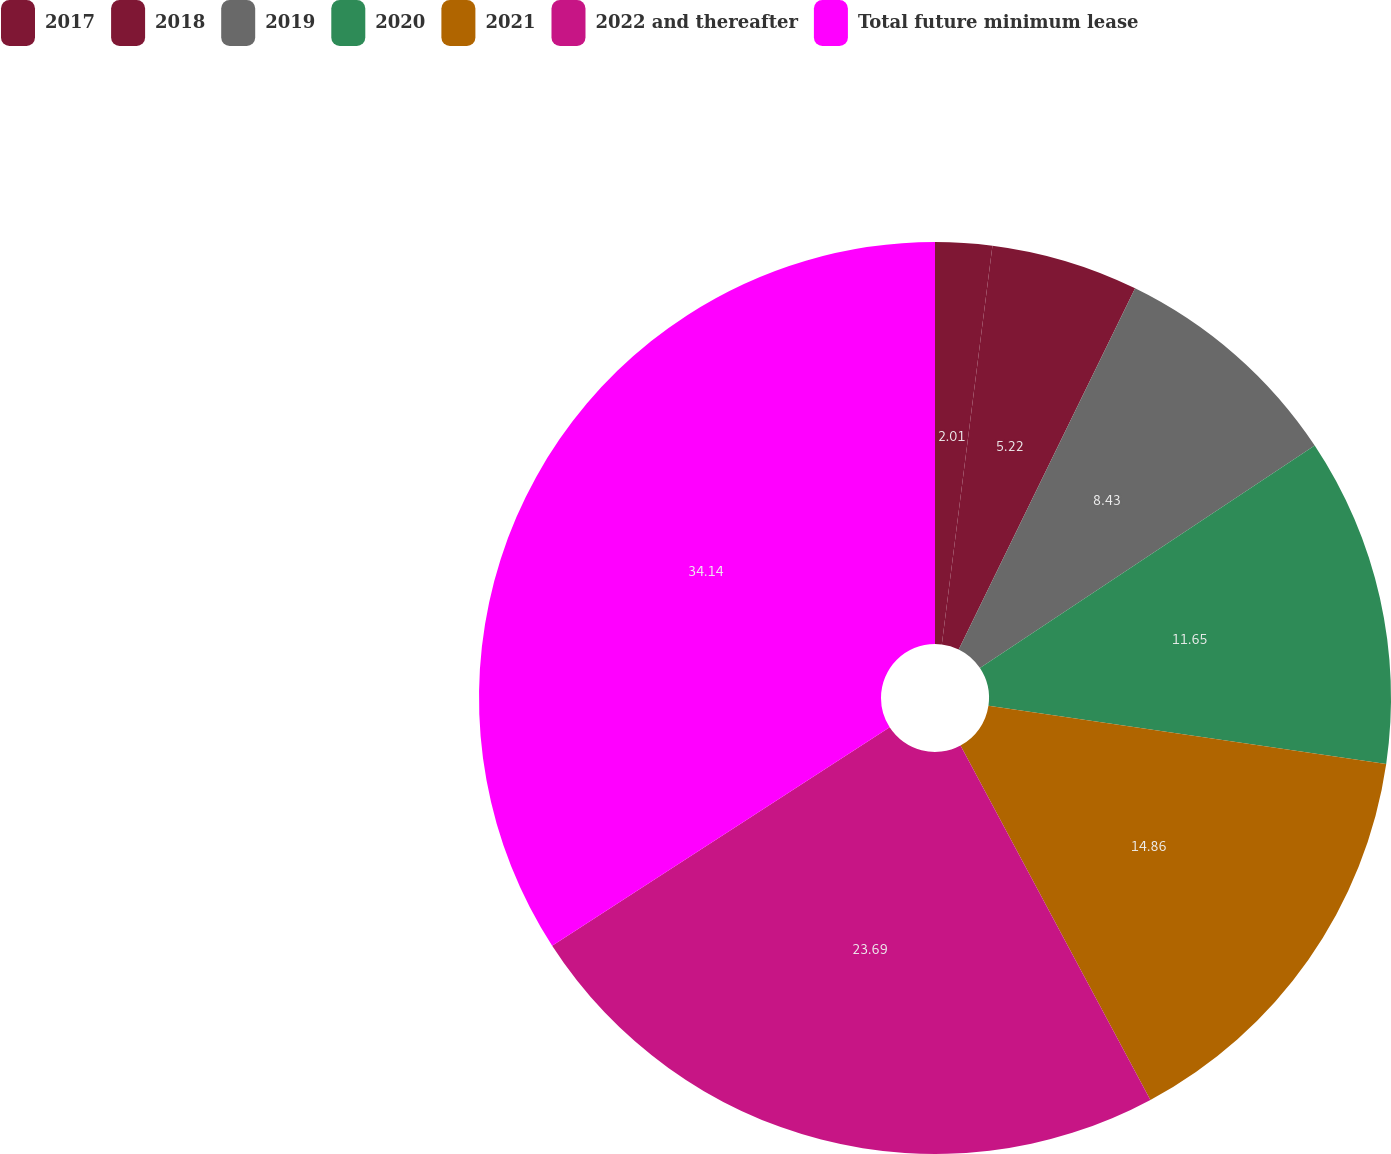Convert chart to OTSL. <chart><loc_0><loc_0><loc_500><loc_500><pie_chart><fcel>2017<fcel>2018<fcel>2019<fcel>2020<fcel>2021<fcel>2022 and thereafter<fcel>Total future minimum lease<nl><fcel>2.01%<fcel>5.22%<fcel>8.43%<fcel>11.65%<fcel>14.86%<fcel>23.69%<fcel>34.14%<nl></chart> 